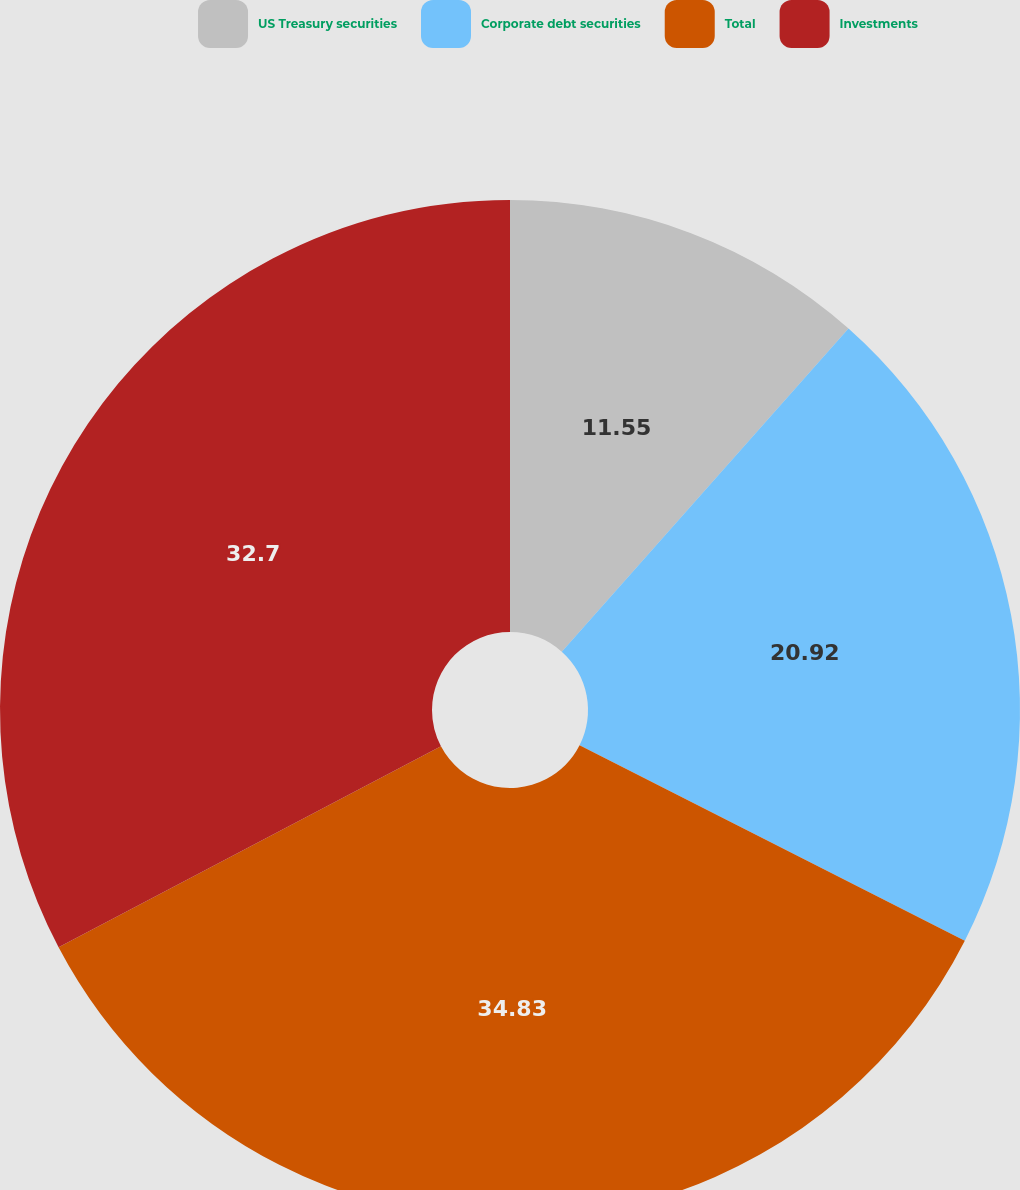Convert chart. <chart><loc_0><loc_0><loc_500><loc_500><pie_chart><fcel>US Treasury securities<fcel>Corporate debt securities<fcel>Total<fcel>Investments<nl><fcel>11.55%<fcel>20.92%<fcel>34.82%<fcel>32.7%<nl></chart> 